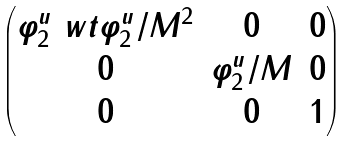<formula> <loc_0><loc_0><loc_500><loc_500>\begin{pmatrix} \varphi ^ { u } _ { 2 } \ w t \varphi ^ { u } _ { 2 } / M ^ { 2 } & 0 & 0 \\ 0 & \varphi ^ { u } _ { 2 } / M & 0 \\ 0 & 0 & 1 \end{pmatrix}</formula> 